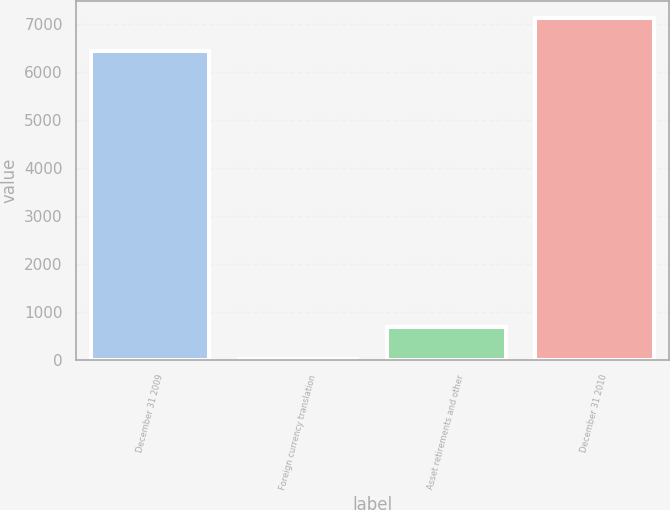<chart> <loc_0><loc_0><loc_500><loc_500><bar_chart><fcel>December 31 2009<fcel>Foreign currency translation<fcel>Asset retirements and other<fcel>December 31 2010<nl><fcel>6448<fcel>19<fcel>696.3<fcel>7125.3<nl></chart> 